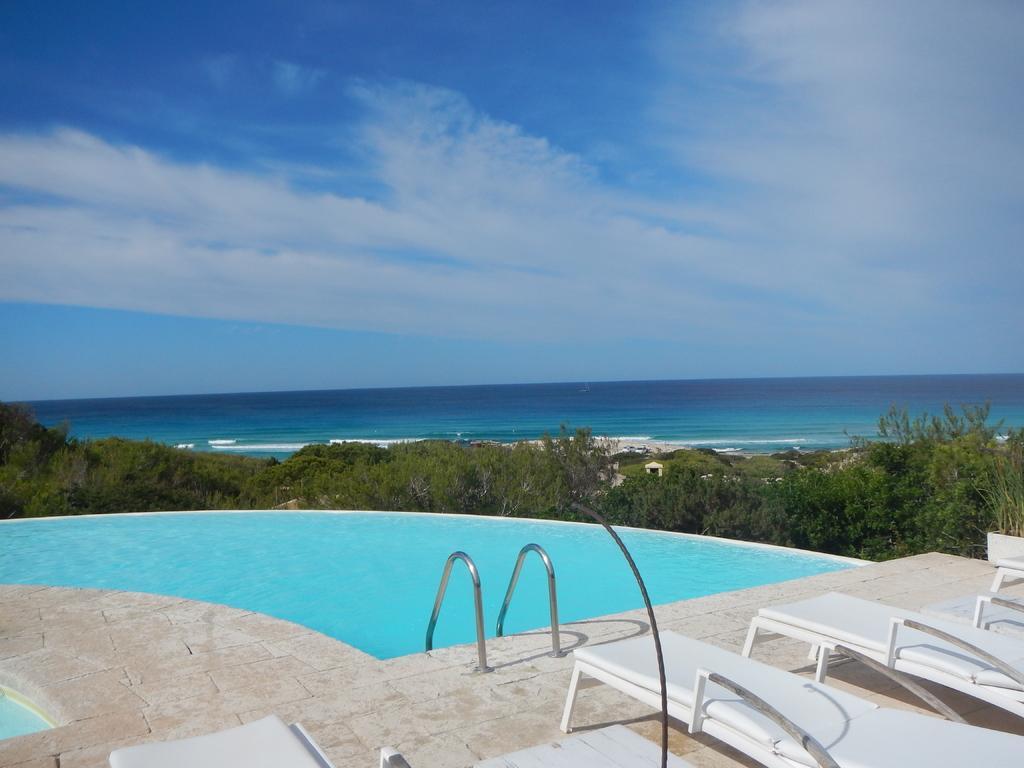How would you summarize this image in a sentence or two? As we can see in the image there is a swimming pool, benches, trees and water. On the top there is sky and clouds. 